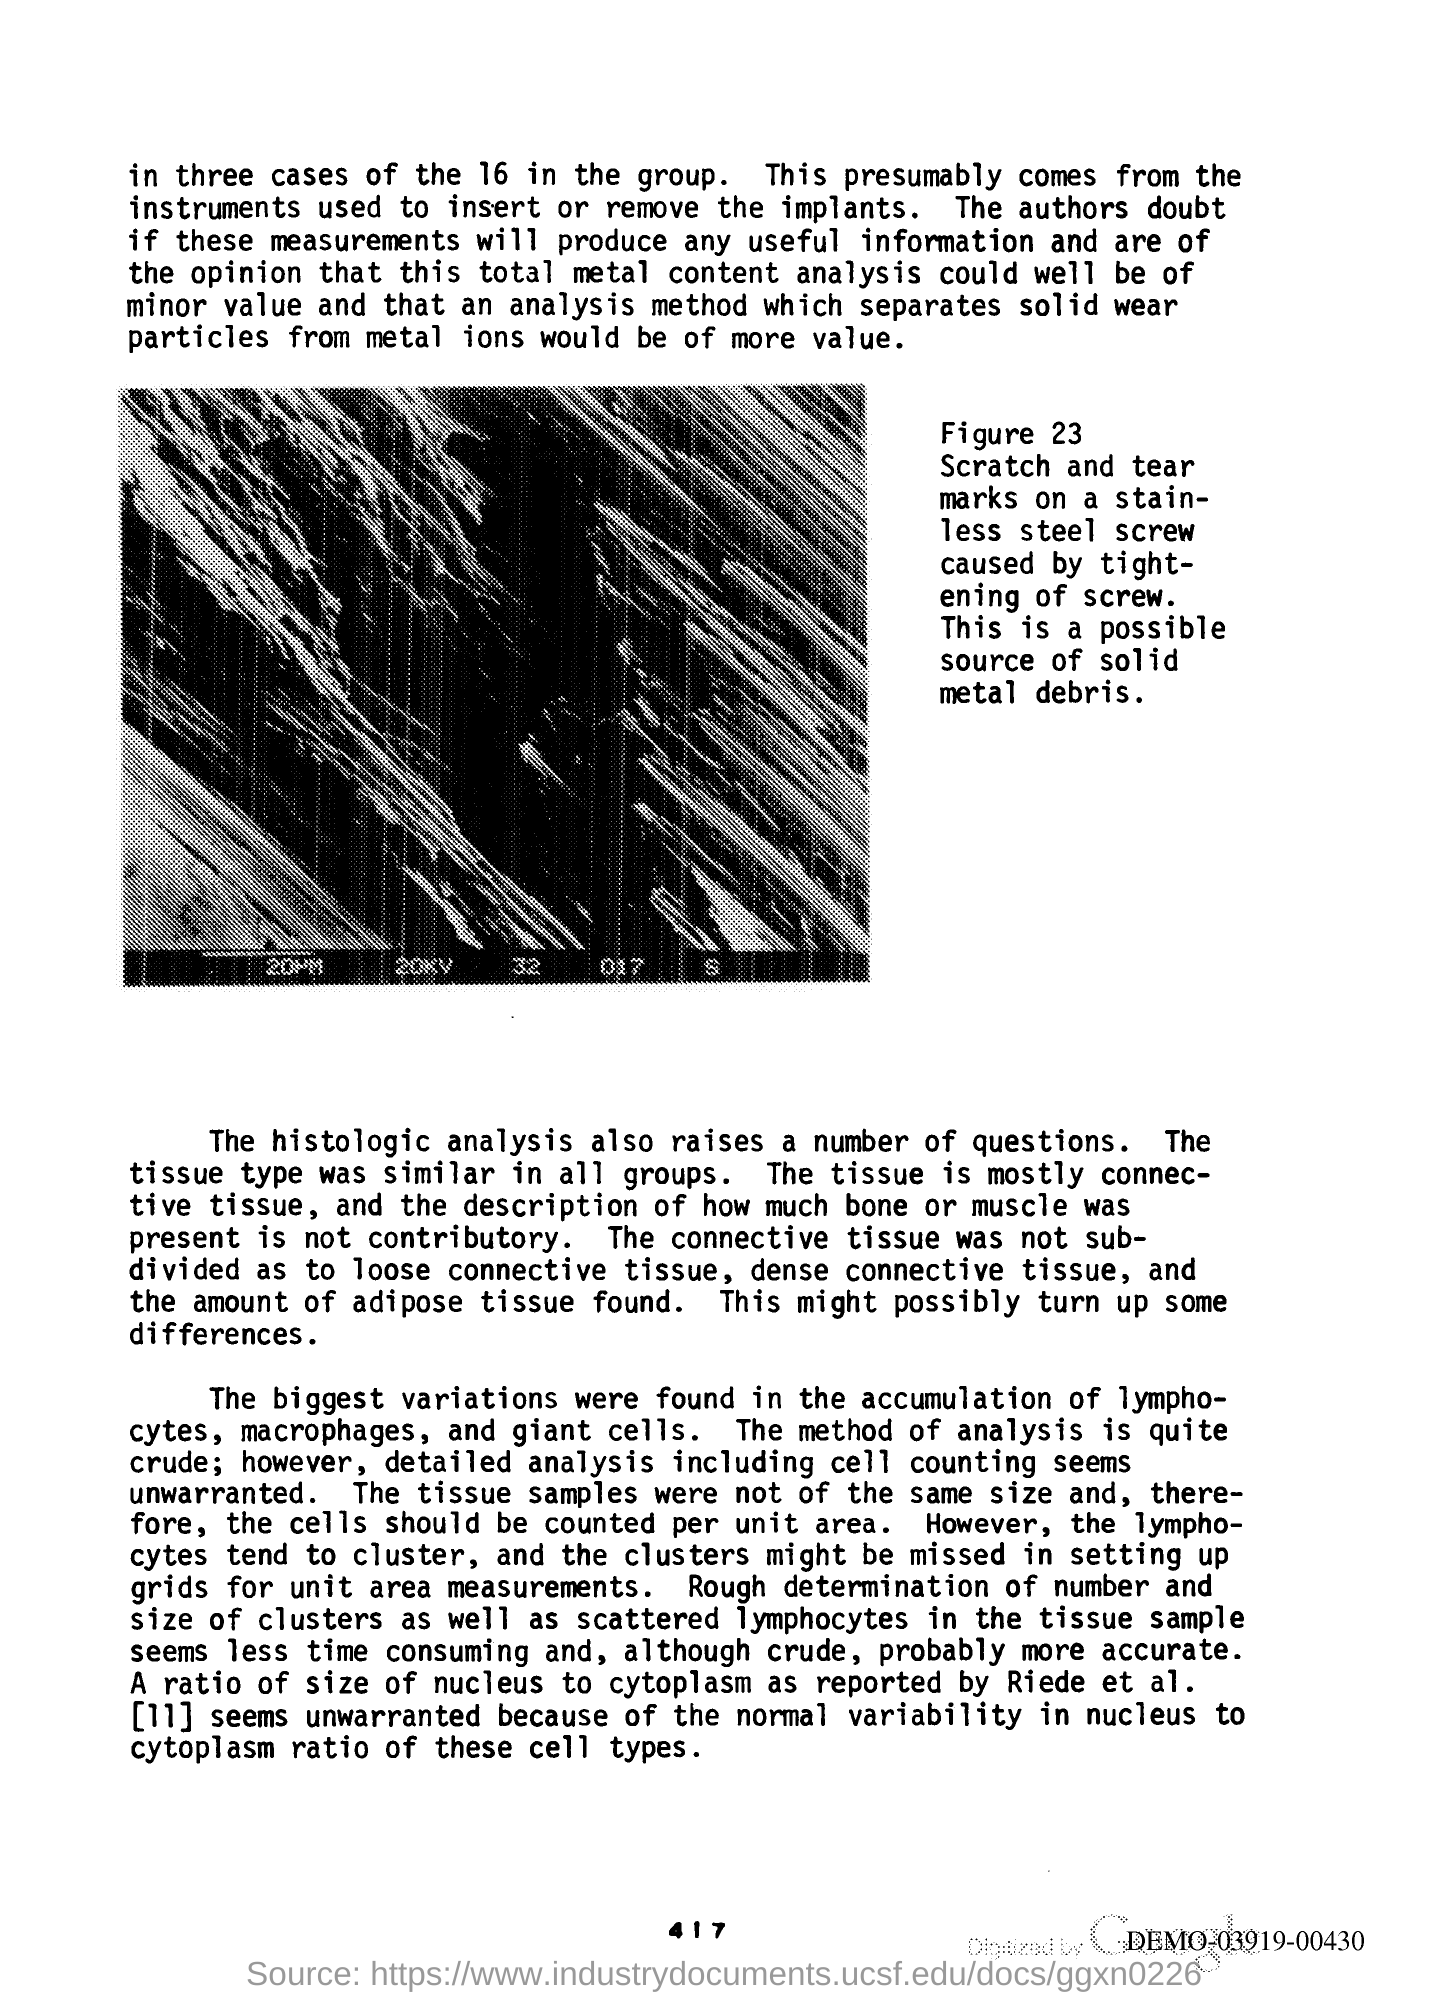What type of tissue is it mostly?
Offer a terse response. Connective tissue. 